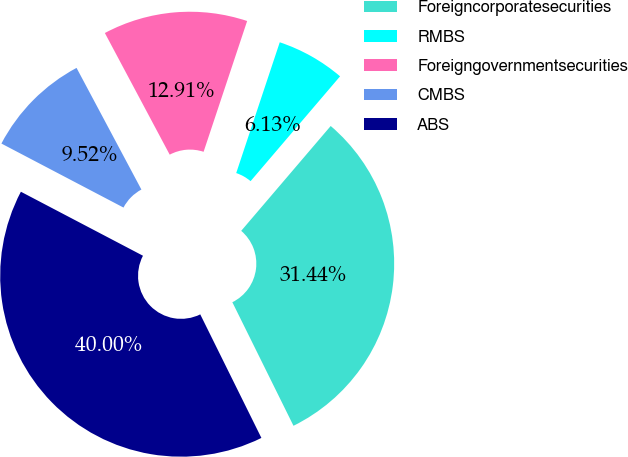Convert chart. <chart><loc_0><loc_0><loc_500><loc_500><pie_chart><fcel>Foreigncorporatesecurities<fcel>RMBS<fcel>Foreigngovernmentsecurities<fcel>CMBS<fcel>ABS<nl><fcel>31.44%<fcel>6.13%<fcel>12.91%<fcel>9.52%<fcel>40.0%<nl></chart> 